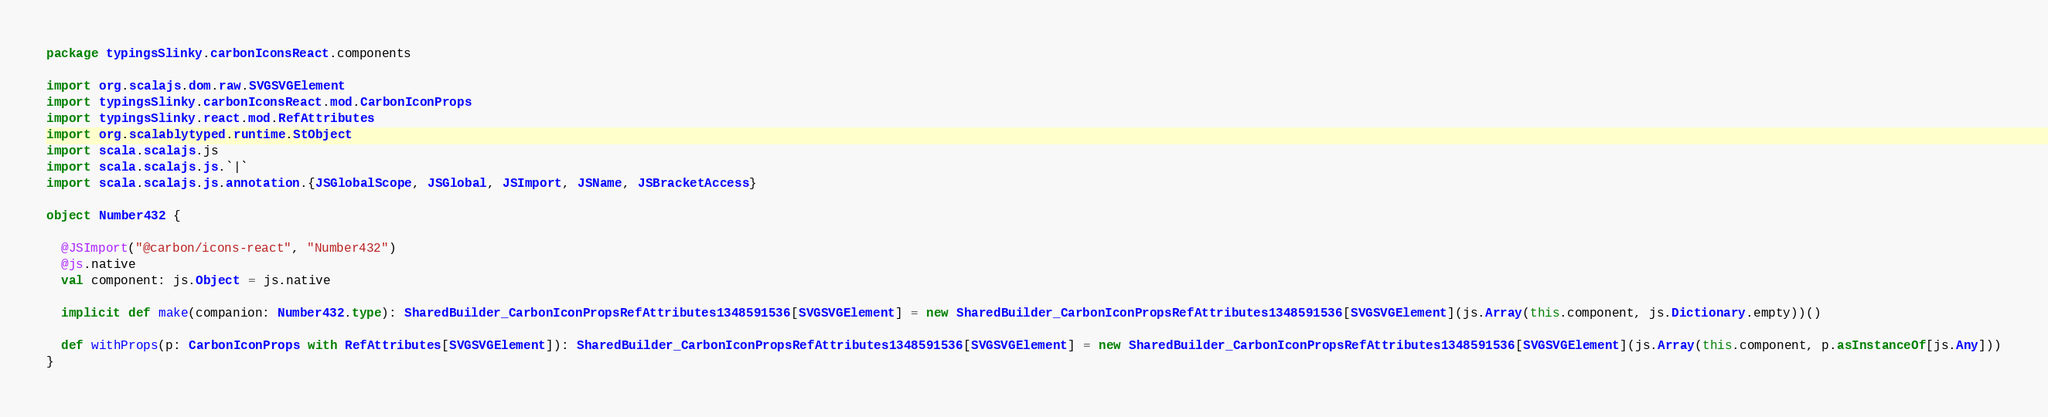Convert code to text. <code><loc_0><loc_0><loc_500><loc_500><_Scala_>package typingsSlinky.carbonIconsReact.components

import org.scalajs.dom.raw.SVGSVGElement
import typingsSlinky.carbonIconsReact.mod.CarbonIconProps
import typingsSlinky.react.mod.RefAttributes
import org.scalablytyped.runtime.StObject
import scala.scalajs.js
import scala.scalajs.js.`|`
import scala.scalajs.js.annotation.{JSGlobalScope, JSGlobal, JSImport, JSName, JSBracketAccess}

object Number432 {
  
  @JSImport("@carbon/icons-react", "Number432")
  @js.native
  val component: js.Object = js.native
  
  implicit def make(companion: Number432.type): SharedBuilder_CarbonIconPropsRefAttributes1348591536[SVGSVGElement] = new SharedBuilder_CarbonIconPropsRefAttributes1348591536[SVGSVGElement](js.Array(this.component, js.Dictionary.empty))()
  
  def withProps(p: CarbonIconProps with RefAttributes[SVGSVGElement]): SharedBuilder_CarbonIconPropsRefAttributes1348591536[SVGSVGElement] = new SharedBuilder_CarbonIconPropsRefAttributes1348591536[SVGSVGElement](js.Array(this.component, p.asInstanceOf[js.Any]))
}
</code> 